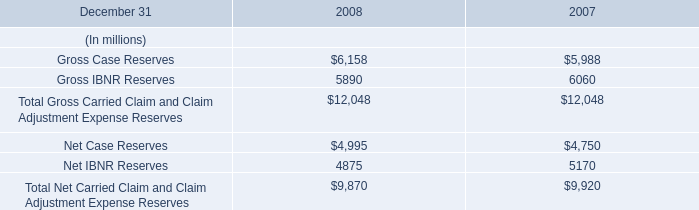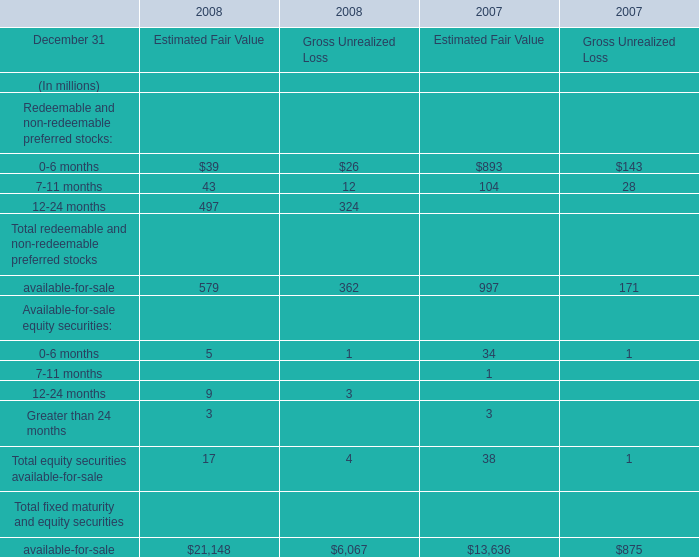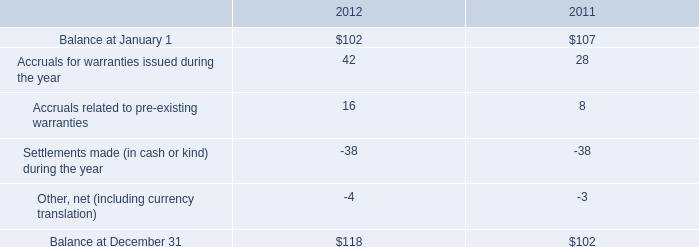What will 7-11 months of Redeemable and non-redeemable preferred stocks for Estimated Fair Value be like in 2009 if it develops with the same increasing rate as current? (in million) 
Computations: (43 * (1 + ((43 - 104) / 104)))
Answer: 17.77885. 